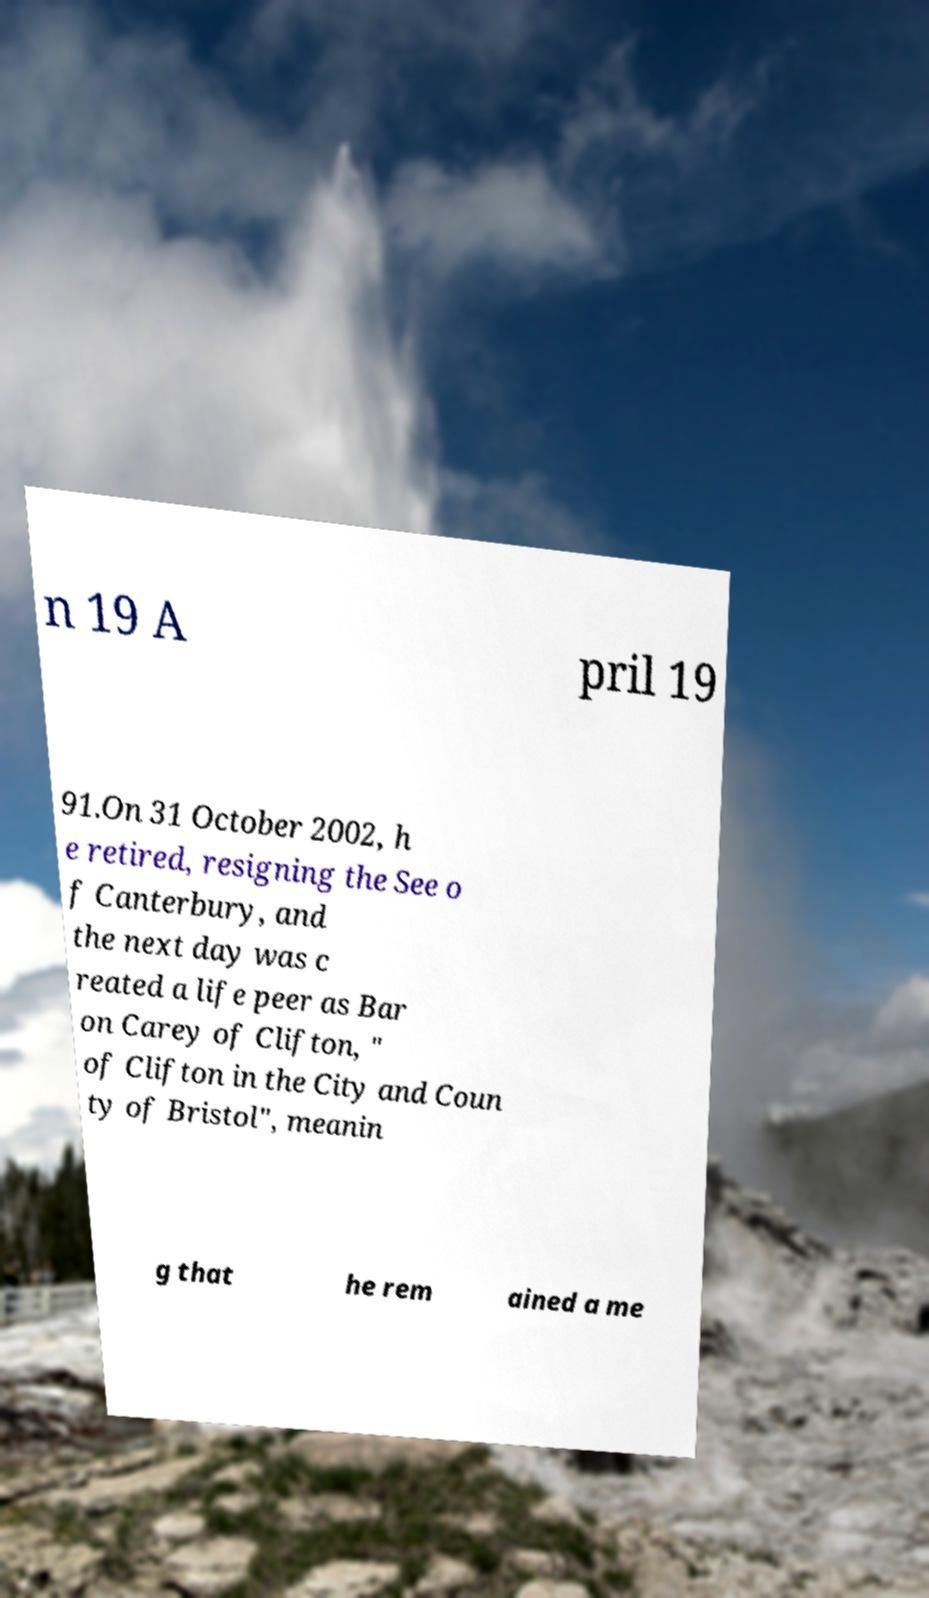There's text embedded in this image that I need extracted. Can you transcribe it verbatim? n 19 A pril 19 91.On 31 October 2002, h e retired, resigning the See o f Canterbury, and the next day was c reated a life peer as Bar on Carey of Clifton, " of Clifton in the City and Coun ty of Bristol", meanin g that he rem ained a me 